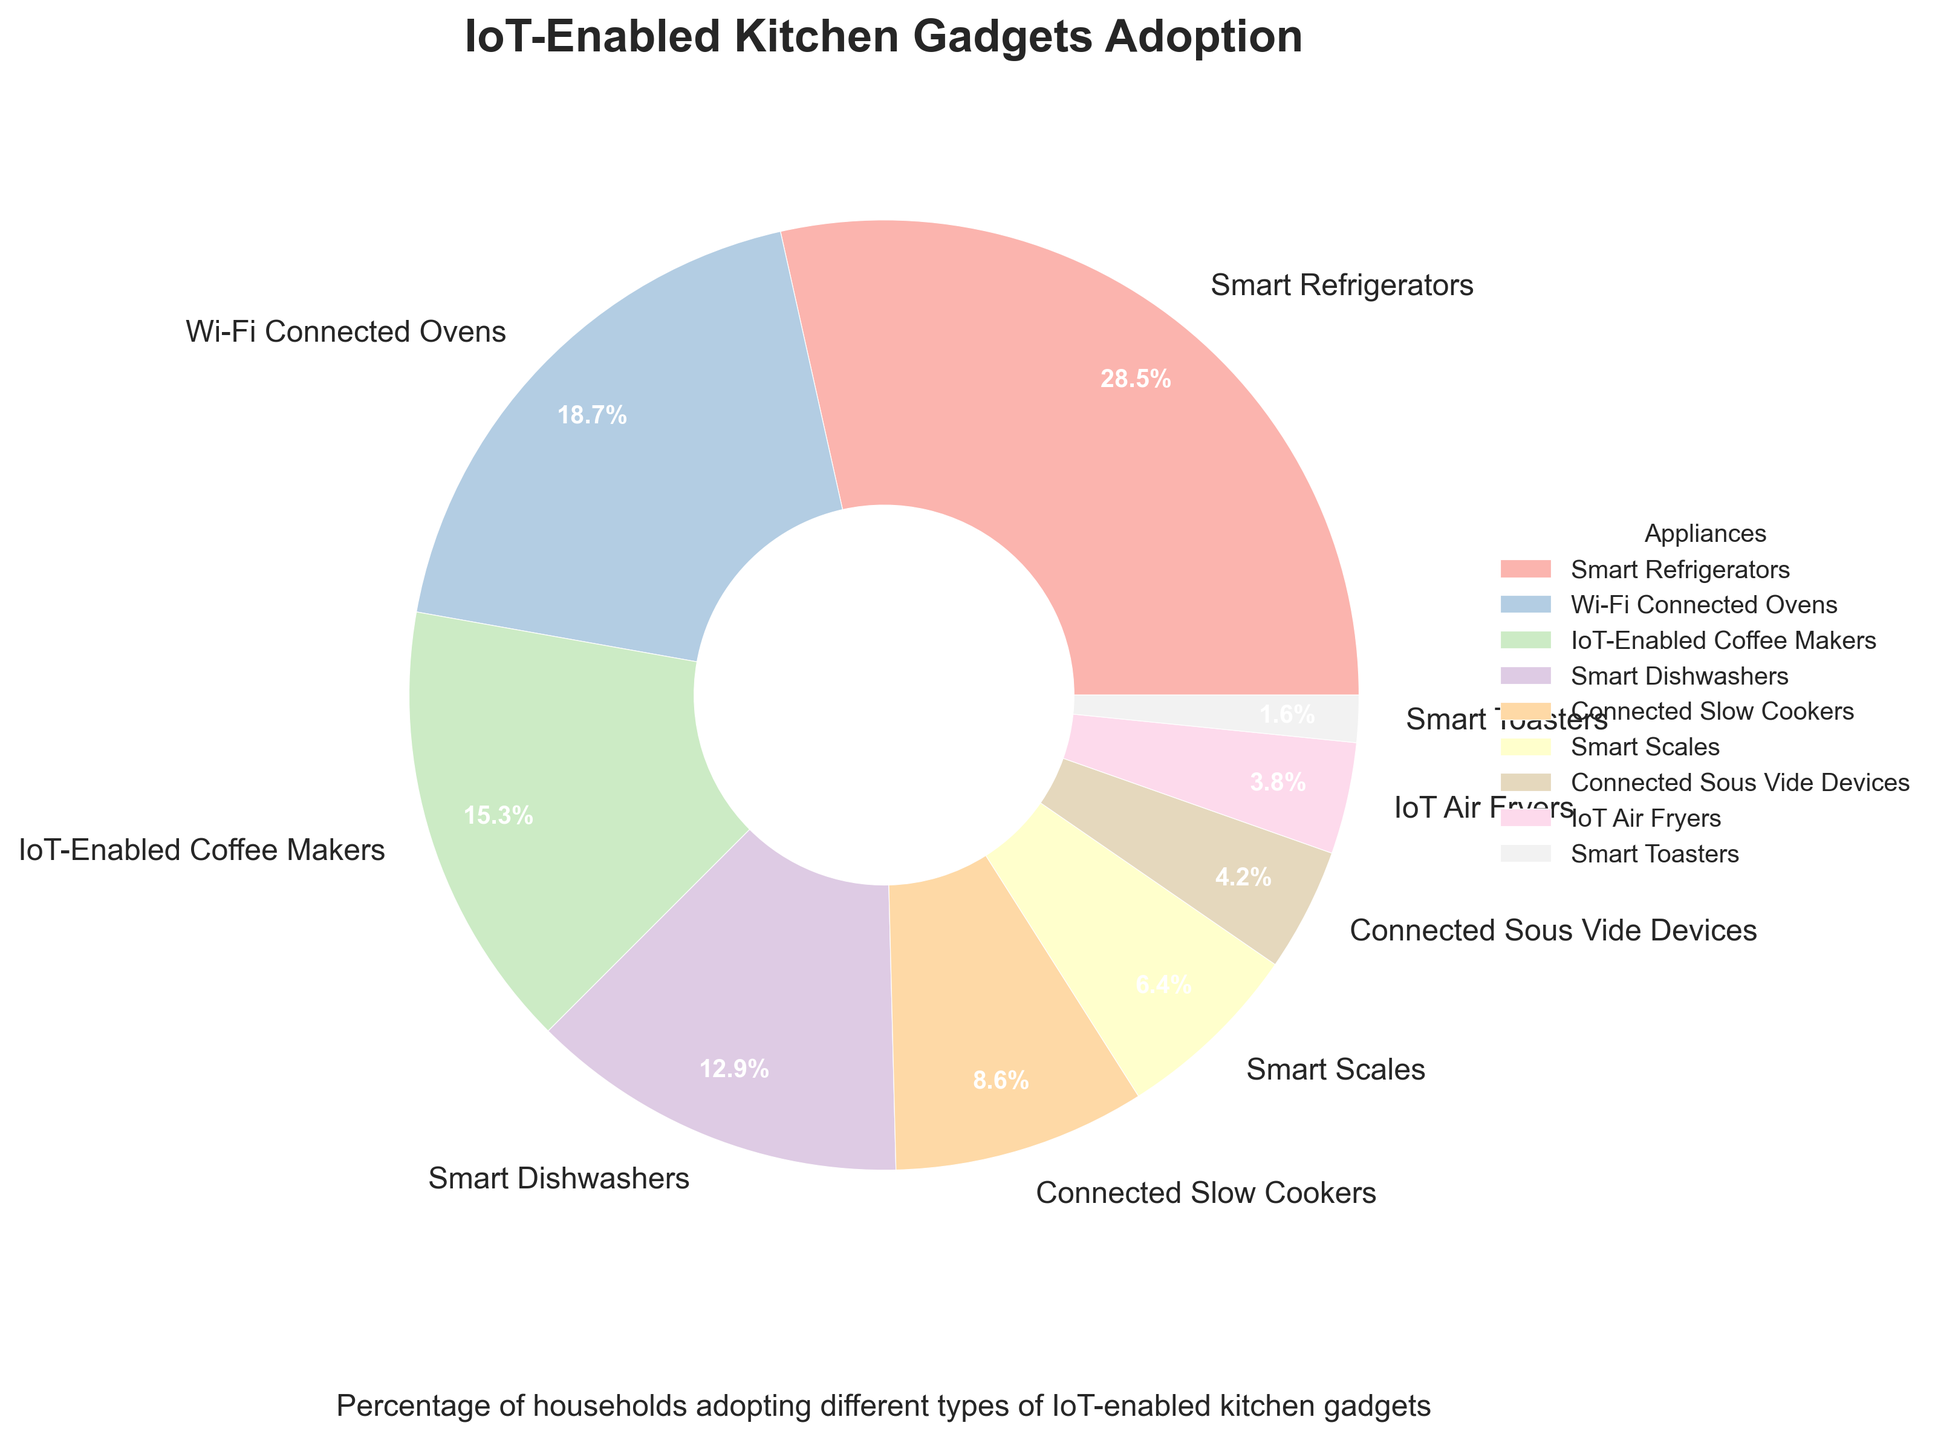Which appliance has the highest percentage of households adopting it? The pie chart shows that Smart Refrigerators have the largest slice, represented by 28.5%.
Answer: Smart Refrigerators Which two appliances have the smallest percentage of adoption? The smallest slices belong to Smart Toasters and IoT Air Fryers, with percentages of 1.6% and 3.8% respectively.
Answer: Smart Toasters and IoT Air Fryers What is the combined adoption percentage of IoT-Enabled Coffee Makers and Smart Dishwashers? Adding the percentages of IoT-Enabled Coffee Makers (15.3%) and Smart Dishwashers (12.9%) gives a combined total of 28.2%.
Answer: 28.2% Are any appliances adopted by more than 20% of households? By examining the slices, only Smart Refrigerators have an adoption percentage greater than 20%, specifically 28.5%.
Answer: Yes, Smart Refrigerators Which appliance has almost half the adoption percentage of Smart Refrigerators? Smart Refrigerators have 28.5%, and Wi-Fi Connected Ovens have 18.7%, which is close to half of Smart Refrigerators' adoption.
Answer: Wi-Fi Connected Ovens Between Connected Slow Cookers and Smart Scales, which appliance has a higher adoption rate, and by how much? Connected Slow Cookers have 8.6% and Smart Scales have 6.4%. The difference is 8.6% - 6.4% = 2.2%.
Answer: Connected Slow Cookers by 2.2% What is the average adoption percentage of the three least adopted appliances? The three least adopted appliances are Smart Toasters (1.6%), IoT Air Fryers (3.8%), and Connected Sous Vide Devices (4.2%). Their average is (1.6 + 3.8 + 4.2) / 3 = 3.2%.
Answer: 3.2% How does the adoption rate of Connected Slow Cookers compare to that of IoT-Enabled Coffee Makers? IoT-Enabled Coffee Makers have a higher adoption rate at 15.3% compared to 8.6% for Connected Slow Cookers.
Answer: IoT-Enabled Coffee Makers have a higher adoption rate What percentage of households use either Smart Scales or Connected Sous Vide Devices? Adding the percentages of Smart Scales (6.4%) and Connected Sous Vide Devices (4.2%) gives a total of 10.6%.
Answer: 10.6% Is the adoption rate of Wi-Fi Connected Ovens more than double that of Smart Toasters? Wi-Fi Connected Ovens have 18.7% while Smart Toasters have 1.6%. Since 18.7 is more than double 1.6 (double of 1.6 is 3.2), the answer is yes.
Answer: Yes 